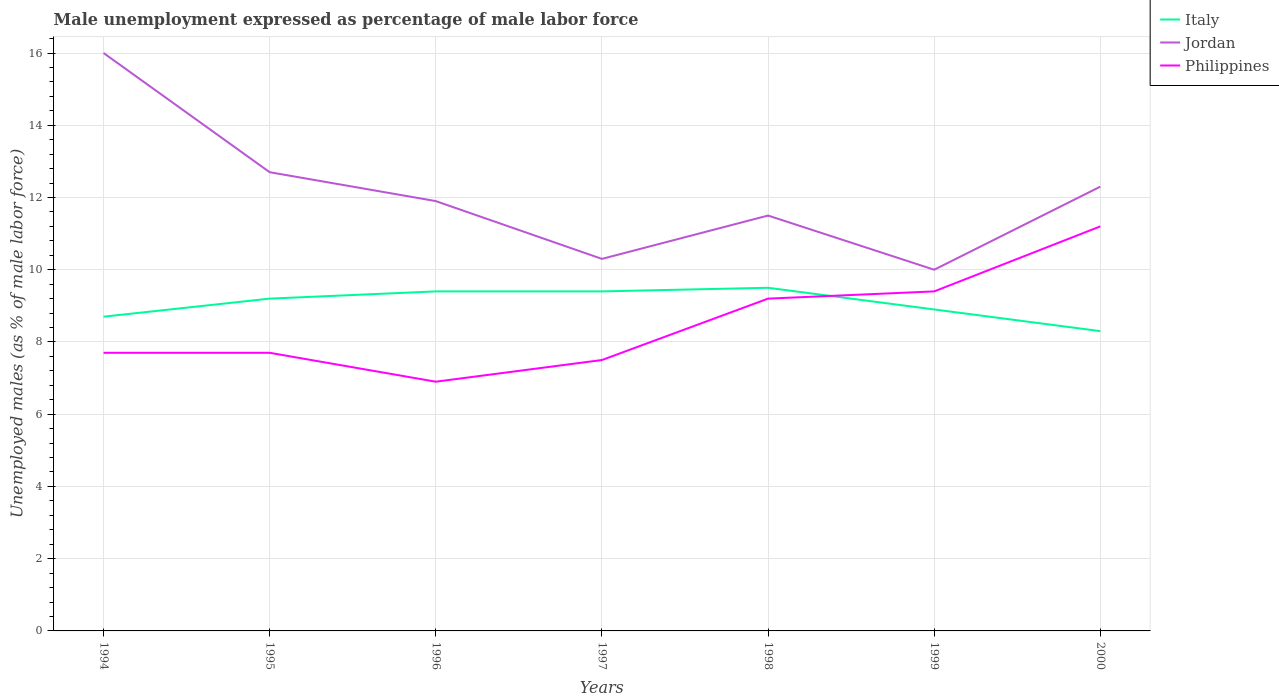Does the line corresponding to Jordan intersect with the line corresponding to Philippines?
Make the answer very short. No. Across all years, what is the maximum unemployment in males in in Italy?
Your answer should be compact. 8.3. In which year was the unemployment in males in in Philippines maximum?
Offer a terse response. 1996. What is the total unemployment in males in in Philippines in the graph?
Ensure brevity in your answer.  -2.3. What is the difference between the highest and the second highest unemployment in males in in Jordan?
Give a very brief answer. 6. What is the difference between the highest and the lowest unemployment in males in in Italy?
Your answer should be compact. 4. Is the unemployment in males in in Italy strictly greater than the unemployment in males in in Philippines over the years?
Ensure brevity in your answer.  No. How many lines are there?
Offer a terse response. 3. How many years are there in the graph?
Your answer should be compact. 7. What is the difference between two consecutive major ticks on the Y-axis?
Offer a terse response. 2. Where does the legend appear in the graph?
Ensure brevity in your answer.  Top right. What is the title of the graph?
Your answer should be very brief. Male unemployment expressed as percentage of male labor force. What is the label or title of the Y-axis?
Provide a succinct answer. Unemployed males (as % of male labor force). What is the Unemployed males (as % of male labor force) of Italy in 1994?
Make the answer very short. 8.7. What is the Unemployed males (as % of male labor force) in Philippines in 1994?
Keep it short and to the point. 7.7. What is the Unemployed males (as % of male labor force) of Italy in 1995?
Provide a short and direct response. 9.2. What is the Unemployed males (as % of male labor force) of Jordan in 1995?
Ensure brevity in your answer.  12.7. What is the Unemployed males (as % of male labor force) of Philippines in 1995?
Your answer should be compact. 7.7. What is the Unemployed males (as % of male labor force) in Italy in 1996?
Your answer should be compact. 9.4. What is the Unemployed males (as % of male labor force) in Jordan in 1996?
Your answer should be very brief. 11.9. What is the Unemployed males (as % of male labor force) in Philippines in 1996?
Offer a very short reply. 6.9. What is the Unemployed males (as % of male labor force) in Italy in 1997?
Offer a terse response. 9.4. What is the Unemployed males (as % of male labor force) in Jordan in 1997?
Give a very brief answer. 10.3. What is the Unemployed males (as % of male labor force) of Jordan in 1998?
Make the answer very short. 11.5. What is the Unemployed males (as % of male labor force) of Philippines in 1998?
Your answer should be very brief. 9.2. What is the Unemployed males (as % of male labor force) in Italy in 1999?
Give a very brief answer. 8.9. What is the Unemployed males (as % of male labor force) in Jordan in 1999?
Offer a very short reply. 10. What is the Unemployed males (as % of male labor force) in Philippines in 1999?
Provide a short and direct response. 9.4. What is the Unemployed males (as % of male labor force) in Italy in 2000?
Provide a succinct answer. 8.3. What is the Unemployed males (as % of male labor force) of Jordan in 2000?
Give a very brief answer. 12.3. What is the Unemployed males (as % of male labor force) in Philippines in 2000?
Keep it short and to the point. 11.2. Across all years, what is the maximum Unemployed males (as % of male labor force) in Jordan?
Provide a short and direct response. 16. Across all years, what is the maximum Unemployed males (as % of male labor force) of Philippines?
Offer a very short reply. 11.2. Across all years, what is the minimum Unemployed males (as % of male labor force) of Italy?
Provide a short and direct response. 8.3. Across all years, what is the minimum Unemployed males (as % of male labor force) in Philippines?
Make the answer very short. 6.9. What is the total Unemployed males (as % of male labor force) in Italy in the graph?
Make the answer very short. 63.4. What is the total Unemployed males (as % of male labor force) of Jordan in the graph?
Make the answer very short. 84.7. What is the total Unemployed males (as % of male labor force) in Philippines in the graph?
Keep it short and to the point. 59.6. What is the difference between the Unemployed males (as % of male labor force) of Jordan in 1994 and that in 1995?
Keep it short and to the point. 3.3. What is the difference between the Unemployed males (as % of male labor force) of Philippines in 1994 and that in 1995?
Provide a short and direct response. 0. What is the difference between the Unemployed males (as % of male labor force) in Jordan in 1994 and that in 1997?
Offer a very short reply. 5.7. What is the difference between the Unemployed males (as % of male labor force) in Italy in 1994 and that in 1998?
Offer a terse response. -0.8. What is the difference between the Unemployed males (as % of male labor force) in Jordan in 1994 and that in 1998?
Ensure brevity in your answer.  4.5. What is the difference between the Unemployed males (as % of male labor force) in Italy in 1994 and that in 1999?
Offer a terse response. -0.2. What is the difference between the Unemployed males (as % of male labor force) in Philippines in 1994 and that in 1999?
Offer a very short reply. -1.7. What is the difference between the Unemployed males (as % of male labor force) of Italy in 1994 and that in 2000?
Keep it short and to the point. 0.4. What is the difference between the Unemployed males (as % of male labor force) in Jordan in 1994 and that in 2000?
Provide a succinct answer. 3.7. What is the difference between the Unemployed males (as % of male labor force) in Italy in 1995 and that in 1996?
Offer a terse response. -0.2. What is the difference between the Unemployed males (as % of male labor force) of Italy in 1995 and that in 1997?
Give a very brief answer. -0.2. What is the difference between the Unemployed males (as % of male labor force) of Philippines in 1995 and that in 1997?
Your answer should be very brief. 0.2. What is the difference between the Unemployed males (as % of male labor force) of Jordan in 1995 and that in 1998?
Provide a short and direct response. 1.2. What is the difference between the Unemployed males (as % of male labor force) in Philippines in 1995 and that in 1998?
Your answer should be very brief. -1.5. What is the difference between the Unemployed males (as % of male labor force) in Jordan in 1995 and that in 1999?
Your answer should be compact. 2.7. What is the difference between the Unemployed males (as % of male labor force) in Philippines in 1995 and that in 1999?
Give a very brief answer. -1.7. What is the difference between the Unemployed males (as % of male labor force) in Jordan in 1995 and that in 2000?
Keep it short and to the point. 0.4. What is the difference between the Unemployed males (as % of male labor force) in Italy in 1996 and that in 1997?
Provide a short and direct response. 0. What is the difference between the Unemployed males (as % of male labor force) in Philippines in 1996 and that in 1997?
Your response must be concise. -0.6. What is the difference between the Unemployed males (as % of male labor force) of Italy in 1996 and that in 1998?
Your answer should be very brief. -0.1. What is the difference between the Unemployed males (as % of male labor force) of Jordan in 1996 and that in 1999?
Keep it short and to the point. 1.9. What is the difference between the Unemployed males (as % of male labor force) of Philippines in 1996 and that in 1999?
Your answer should be very brief. -2.5. What is the difference between the Unemployed males (as % of male labor force) of Italy in 1996 and that in 2000?
Your answer should be very brief. 1.1. What is the difference between the Unemployed males (as % of male labor force) in Jordan in 1996 and that in 2000?
Provide a succinct answer. -0.4. What is the difference between the Unemployed males (as % of male labor force) of Philippines in 1997 and that in 1998?
Give a very brief answer. -1.7. What is the difference between the Unemployed males (as % of male labor force) in Jordan in 1997 and that in 1999?
Provide a succinct answer. 0.3. What is the difference between the Unemployed males (as % of male labor force) in Philippines in 1997 and that in 2000?
Your answer should be compact. -3.7. What is the difference between the Unemployed males (as % of male labor force) in Jordan in 1998 and that in 1999?
Make the answer very short. 1.5. What is the difference between the Unemployed males (as % of male labor force) of Philippines in 1998 and that in 1999?
Your answer should be compact. -0.2. What is the difference between the Unemployed males (as % of male labor force) in Italy in 1998 and that in 2000?
Keep it short and to the point. 1.2. What is the difference between the Unemployed males (as % of male labor force) of Philippines in 1998 and that in 2000?
Your answer should be compact. -2. What is the difference between the Unemployed males (as % of male labor force) of Jordan in 1999 and that in 2000?
Give a very brief answer. -2.3. What is the difference between the Unemployed males (as % of male labor force) of Italy in 1994 and the Unemployed males (as % of male labor force) of Philippines in 1995?
Offer a very short reply. 1. What is the difference between the Unemployed males (as % of male labor force) of Jordan in 1994 and the Unemployed males (as % of male labor force) of Philippines in 1995?
Keep it short and to the point. 8.3. What is the difference between the Unemployed males (as % of male labor force) in Italy in 1994 and the Unemployed males (as % of male labor force) in Philippines in 1996?
Provide a short and direct response. 1.8. What is the difference between the Unemployed males (as % of male labor force) in Jordan in 1994 and the Unemployed males (as % of male labor force) in Philippines in 1996?
Provide a short and direct response. 9.1. What is the difference between the Unemployed males (as % of male labor force) of Italy in 1994 and the Unemployed males (as % of male labor force) of Jordan in 1998?
Your answer should be very brief. -2.8. What is the difference between the Unemployed males (as % of male labor force) in Jordan in 1994 and the Unemployed males (as % of male labor force) in Philippines in 1998?
Your answer should be very brief. 6.8. What is the difference between the Unemployed males (as % of male labor force) in Italy in 1994 and the Unemployed males (as % of male labor force) in Jordan in 1999?
Ensure brevity in your answer.  -1.3. What is the difference between the Unemployed males (as % of male labor force) of Italy in 1994 and the Unemployed males (as % of male labor force) of Philippines in 2000?
Make the answer very short. -2.5. What is the difference between the Unemployed males (as % of male labor force) of Italy in 1995 and the Unemployed males (as % of male labor force) of Jordan in 1996?
Provide a short and direct response. -2.7. What is the difference between the Unemployed males (as % of male labor force) of Italy in 1995 and the Unemployed males (as % of male labor force) of Philippines in 1997?
Your answer should be very brief. 1.7. What is the difference between the Unemployed males (as % of male labor force) in Italy in 1995 and the Unemployed males (as % of male labor force) in Jordan in 1998?
Your answer should be very brief. -2.3. What is the difference between the Unemployed males (as % of male labor force) in Italy in 1995 and the Unemployed males (as % of male labor force) in Philippines in 1998?
Offer a terse response. 0. What is the difference between the Unemployed males (as % of male labor force) of Italy in 1995 and the Unemployed males (as % of male labor force) of Jordan in 1999?
Give a very brief answer. -0.8. What is the difference between the Unemployed males (as % of male labor force) in Italy in 1995 and the Unemployed males (as % of male labor force) in Philippines in 1999?
Your response must be concise. -0.2. What is the difference between the Unemployed males (as % of male labor force) in Jordan in 1995 and the Unemployed males (as % of male labor force) in Philippines in 1999?
Ensure brevity in your answer.  3.3. What is the difference between the Unemployed males (as % of male labor force) of Italy in 1995 and the Unemployed males (as % of male labor force) of Jordan in 2000?
Provide a succinct answer. -3.1. What is the difference between the Unemployed males (as % of male labor force) of Jordan in 1995 and the Unemployed males (as % of male labor force) of Philippines in 2000?
Offer a very short reply. 1.5. What is the difference between the Unemployed males (as % of male labor force) of Italy in 1996 and the Unemployed males (as % of male labor force) of Jordan in 1997?
Your answer should be compact. -0.9. What is the difference between the Unemployed males (as % of male labor force) in Italy in 1996 and the Unemployed males (as % of male labor force) in Philippines in 1997?
Your response must be concise. 1.9. What is the difference between the Unemployed males (as % of male labor force) of Jordan in 1996 and the Unemployed males (as % of male labor force) of Philippines in 1997?
Offer a terse response. 4.4. What is the difference between the Unemployed males (as % of male labor force) in Italy in 1996 and the Unemployed males (as % of male labor force) in Philippines in 1998?
Your answer should be very brief. 0.2. What is the difference between the Unemployed males (as % of male labor force) in Jordan in 1996 and the Unemployed males (as % of male labor force) in Philippines in 1998?
Ensure brevity in your answer.  2.7. What is the difference between the Unemployed males (as % of male labor force) of Italy in 1996 and the Unemployed males (as % of male labor force) of Philippines in 1999?
Your answer should be very brief. 0. What is the difference between the Unemployed males (as % of male labor force) of Italy in 1996 and the Unemployed males (as % of male labor force) of Jordan in 2000?
Your answer should be very brief. -2.9. What is the difference between the Unemployed males (as % of male labor force) of Italy in 1997 and the Unemployed males (as % of male labor force) of Philippines in 1998?
Provide a short and direct response. 0.2. What is the difference between the Unemployed males (as % of male labor force) in Jordan in 1997 and the Unemployed males (as % of male labor force) in Philippines in 1998?
Provide a short and direct response. 1.1. What is the difference between the Unemployed males (as % of male labor force) of Italy in 1997 and the Unemployed males (as % of male labor force) of Jordan in 1999?
Give a very brief answer. -0.6. What is the difference between the Unemployed males (as % of male labor force) of Italy in 1998 and the Unemployed males (as % of male labor force) of Jordan in 1999?
Your answer should be very brief. -0.5. What is the difference between the Unemployed males (as % of male labor force) of Jordan in 1998 and the Unemployed males (as % of male labor force) of Philippines in 1999?
Keep it short and to the point. 2.1. What is the difference between the Unemployed males (as % of male labor force) of Italy in 1998 and the Unemployed males (as % of male labor force) of Philippines in 2000?
Ensure brevity in your answer.  -1.7. What is the difference between the Unemployed males (as % of male labor force) of Jordan in 1999 and the Unemployed males (as % of male labor force) of Philippines in 2000?
Make the answer very short. -1.2. What is the average Unemployed males (as % of male labor force) of Italy per year?
Keep it short and to the point. 9.06. What is the average Unemployed males (as % of male labor force) of Jordan per year?
Provide a succinct answer. 12.1. What is the average Unemployed males (as % of male labor force) of Philippines per year?
Make the answer very short. 8.51. In the year 1994, what is the difference between the Unemployed males (as % of male labor force) in Jordan and Unemployed males (as % of male labor force) in Philippines?
Offer a very short reply. 8.3. In the year 1995, what is the difference between the Unemployed males (as % of male labor force) of Jordan and Unemployed males (as % of male labor force) of Philippines?
Your response must be concise. 5. In the year 1996, what is the difference between the Unemployed males (as % of male labor force) of Jordan and Unemployed males (as % of male labor force) of Philippines?
Make the answer very short. 5. In the year 1997, what is the difference between the Unemployed males (as % of male labor force) of Italy and Unemployed males (as % of male labor force) of Jordan?
Ensure brevity in your answer.  -0.9. In the year 1997, what is the difference between the Unemployed males (as % of male labor force) of Italy and Unemployed males (as % of male labor force) of Philippines?
Provide a succinct answer. 1.9. In the year 1997, what is the difference between the Unemployed males (as % of male labor force) of Jordan and Unemployed males (as % of male labor force) of Philippines?
Provide a succinct answer. 2.8. In the year 1998, what is the difference between the Unemployed males (as % of male labor force) in Italy and Unemployed males (as % of male labor force) in Jordan?
Ensure brevity in your answer.  -2. In the year 1998, what is the difference between the Unemployed males (as % of male labor force) in Italy and Unemployed males (as % of male labor force) in Philippines?
Your answer should be very brief. 0.3. In the year 1999, what is the difference between the Unemployed males (as % of male labor force) of Italy and Unemployed males (as % of male labor force) of Jordan?
Your response must be concise. -1.1. In the year 1999, what is the difference between the Unemployed males (as % of male labor force) of Italy and Unemployed males (as % of male labor force) of Philippines?
Your answer should be compact. -0.5. In the year 2000, what is the difference between the Unemployed males (as % of male labor force) in Italy and Unemployed males (as % of male labor force) in Jordan?
Ensure brevity in your answer.  -4. In the year 2000, what is the difference between the Unemployed males (as % of male labor force) in Italy and Unemployed males (as % of male labor force) in Philippines?
Offer a terse response. -2.9. What is the ratio of the Unemployed males (as % of male labor force) of Italy in 1994 to that in 1995?
Ensure brevity in your answer.  0.95. What is the ratio of the Unemployed males (as % of male labor force) of Jordan in 1994 to that in 1995?
Keep it short and to the point. 1.26. What is the ratio of the Unemployed males (as % of male labor force) in Italy in 1994 to that in 1996?
Ensure brevity in your answer.  0.93. What is the ratio of the Unemployed males (as % of male labor force) in Jordan in 1994 to that in 1996?
Provide a succinct answer. 1.34. What is the ratio of the Unemployed males (as % of male labor force) of Philippines in 1994 to that in 1996?
Offer a very short reply. 1.12. What is the ratio of the Unemployed males (as % of male labor force) in Italy in 1994 to that in 1997?
Provide a short and direct response. 0.93. What is the ratio of the Unemployed males (as % of male labor force) in Jordan in 1994 to that in 1997?
Your response must be concise. 1.55. What is the ratio of the Unemployed males (as % of male labor force) in Philippines in 1994 to that in 1997?
Offer a terse response. 1.03. What is the ratio of the Unemployed males (as % of male labor force) of Italy in 1994 to that in 1998?
Your answer should be very brief. 0.92. What is the ratio of the Unemployed males (as % of male labor force) of Jordan in 1994 to that in 1998?
Give a very brief answer. 1.39. What is the ratio of the Unemployed males (as % of male labor force) of Philippines in 1994 to that in 1998?
Ensure brevity in your answer.  0.84. What is the ratio of the Unemployed males (as % of male labor force) of Italy in 1994 to that in 1999?
Provide a succinct answer. 0.98. What is the ratio of the Unemployed males (as % of male labor force) of Jordan in 1994 to that in 1999?
Offer a very short reply. 1.6. What is the ratio of the Unemployed males (as % of male labor force) of Philippines in 1994 to that in 1999?
Offer a very short reply. 0.82. What is the ratio of the Unemployed males (as % of male labor force) of Italy in 1994 to that in 2000?
Ensure brevity in your answer.  1.05. What is the ratio of the Unemployed males (as % of male labor force) in Jordan in 1994 to that in 2000?
Your response must be concise. 1.3. What is the ratio of the Unemployed males (as % of male labor force) in Philippines in 1994 to that in 2000?
Offer a very short reply. 0.69. What is the ratio of the Unemployed males (as % of male labor force) of Italy in 1995 to that in 1996?
Your answer should be very brief. 0.98. What is the ratio of the Unemployed males (as % of male labor force) in Jordan in 1995 to that in 1996?
Your answer should be compact. 1.07. What is the ratio of the Unemployed males (as % of male labor force) in Philippines in 1995 to that in 1996?
Provide a short and direct response. 1.12. What is the ratio of the Unemployed males (as % of male labor force) in Italy in 1995 to that in 1997?
Make the answer very short. 0.98. What is the ratio of the Unemployed males (as % of male labor force) of Jordan in 1995 to that in 1997?
Provide a short and direct response. 1.23. What is the ratio of the Unemployed males (as % of male labor force) in Philippines in 1995 to that in 1997?
Give a very brief answer. 1.03. What is the ratio of the Unemployed males (as % of male labor force) of Italy in 1995 to that in 1998?
Ensure brevity in your answer.  0.97. What is the ratio of the Unemployed males (as % of male labor force) in Jordan in 1995 to that in 1998?
Give a very brief answer. 1.1. What is the ratio of the Unemployed males (as % of male labor force) in Philippines in 1995 to that in 1998?
Offer a very short reply. 0.84. What is the ratio of the Unemployed males (as % of male labor force) of Italy in 1995 to that in 1999?
Your answer should be compact. 1.03. What is the ratio of the Unemployed males (as % of male labor force) in Jordan in 1995 to that in 1999?
Offer a very short reply. 1.27. What is the ratio of the Unemployed males (as % of male labor force) in Philippines in 1995 to that in 1999?
Offer a very short reply. 0.82. What is the ratio of the Unemployed males (as % of male labor force) in Italy in 1995 to that in 2000?
Give a very brief answer. 1.11. What is the ratio of the Unemployed males (as % of male labor force) in Jordan in 1995 to that in 2000?
Your response must be concise. 1.03. What is the ratio of the Unemployed males (as % of male labor force) in Philippines in 1995 to that in 2000?
Your answer should be compact. 0.69. What is the ratio of the Unemployed males (as % of male labor force) in Jordan in 1996 to that in 1997?
Offer a terse response. 1.16. What is the ratio of the Unemployed males (as % of male labor force) of Philippines in 1996 to that in 1997?
Offer a terse response. 0.92. What is the ratio of the Unemployed males (as % of male labor force) in Jordan in 1996 to that in 1998?
Provide a succinct answer. 1.03. What is the ratio of the Unemployed males (as % of male labor force) of Philippines in 1996 to that in 1998?
Your response must be concise. 0.75. What is the ratio of the Unemployed males (as % of male labor force) of Italy in 1996 to that in 1999?
Your answer should be very brief. 1.06. What is the ratio of the Unemployed males (as % of male labor force) in Jordan in 1996 to that in 1999?
Keep it short and to the point. 1.19. What is the ratio of the Unemployed males (as % of male labor force) in Philippines in 1996 to that in 1999?
Offer a terse response. 0.73. What is the ratio of the Unemployed males (as % of male labor force) in Italy in 1996 to that in 2000?
Offer a terse response. 1.13. What is the ratio of the Unemployed males (as % of male labor force) in Jordan in 1996 to that in 2000?
Offer a very short reply. 0.97. What is the ratio of the Unemployed males (as % of male labor force) of Philippines in 1996 to that in 2000?
Give a very brief answer. 0.62. What is the ratio of the Unemployed males (as % of male labor force) of Jordan in 1997 to that in 1998?
Give a very brief answer. 0.9. What is the ratio of the Unemployed males (as % of male labor force) of Philippines in 1997 to that in 1998?
Your answer should be very brief. 0.82. What is the ratio of the Unemployed males (as % of male labor force) of Italy in 1997 to that in 1999?
Your answer should be very brief. 1.06. What is the ratio of the Unemployed males (as % of male labor force) in Philippines in 1997 to that in 1999?
Your response must be concise. 0.8. What is the ratio of the Unemployed males (as % of male labor force) of Italy in 1997 to that in 2000?
Offer a very short reply. 1.13. What is the ratio of the Unemployed males (as % of male labor force) in Jordan in 1997 to that in 2000?
Give a very brief answer. 0.84. What is the ratio of the Unemployed males (as % of male labor force) of Philippines in 1997 to that in 2000?
Offer a very short reply. 0.67. What is the ratio of the Unemployed males (as % of male labor force) in Italy in 1998 to that in 1999?
Your response must be concise. 1.07. What is the ratio of the Unemployed males (as % of male labor force) in Jordan in 1998 to that in 1999?
Provide a succinct answer. 1.15. What is the ratio of the Unemployed males (as % of male labor force) in Philippines in 1998 to that in 1999?
Provide a short and direct response. 0.98. What is the ratio of the Unemployed males (as % of male labor force) of Italy in 1998 to that in 2000?
Your answer should be very brief. 1.14. What is the ratio of the Unemployed males (as % of male labor force) in Jordan in 1998 to that in 2000?
Ensure brevity in your answer.  0.94. What is the ratio of the Unemployed males (as % of male labor force) of Philippines in 1998 to that in 2000?
Give a very brief answer. 0.82. What is the ratio of the Unemployed males (as % of male labor force) in Italy in 1999 to that in 2000?
Keep it short and to the point. 1.07. What is the ratio of the Unemployed males (as % of male labor force) in Jordan in 1999 to that in 2000?
Give a very brief answer. 0.81. What is the ratio of the Unemployed males (as % of male labor force) of Philippines in 1999 to that in 2000?
Give a very brief answer. 0.84. What is the difference between the highest and the lowest Unemployed males (as % of male labor force) in Italy?
Make the answer very short. 1.2. 